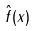<formula> <loc_0><loc_0><loc_500><loc_500>\hat { f } ( x )</formula> 